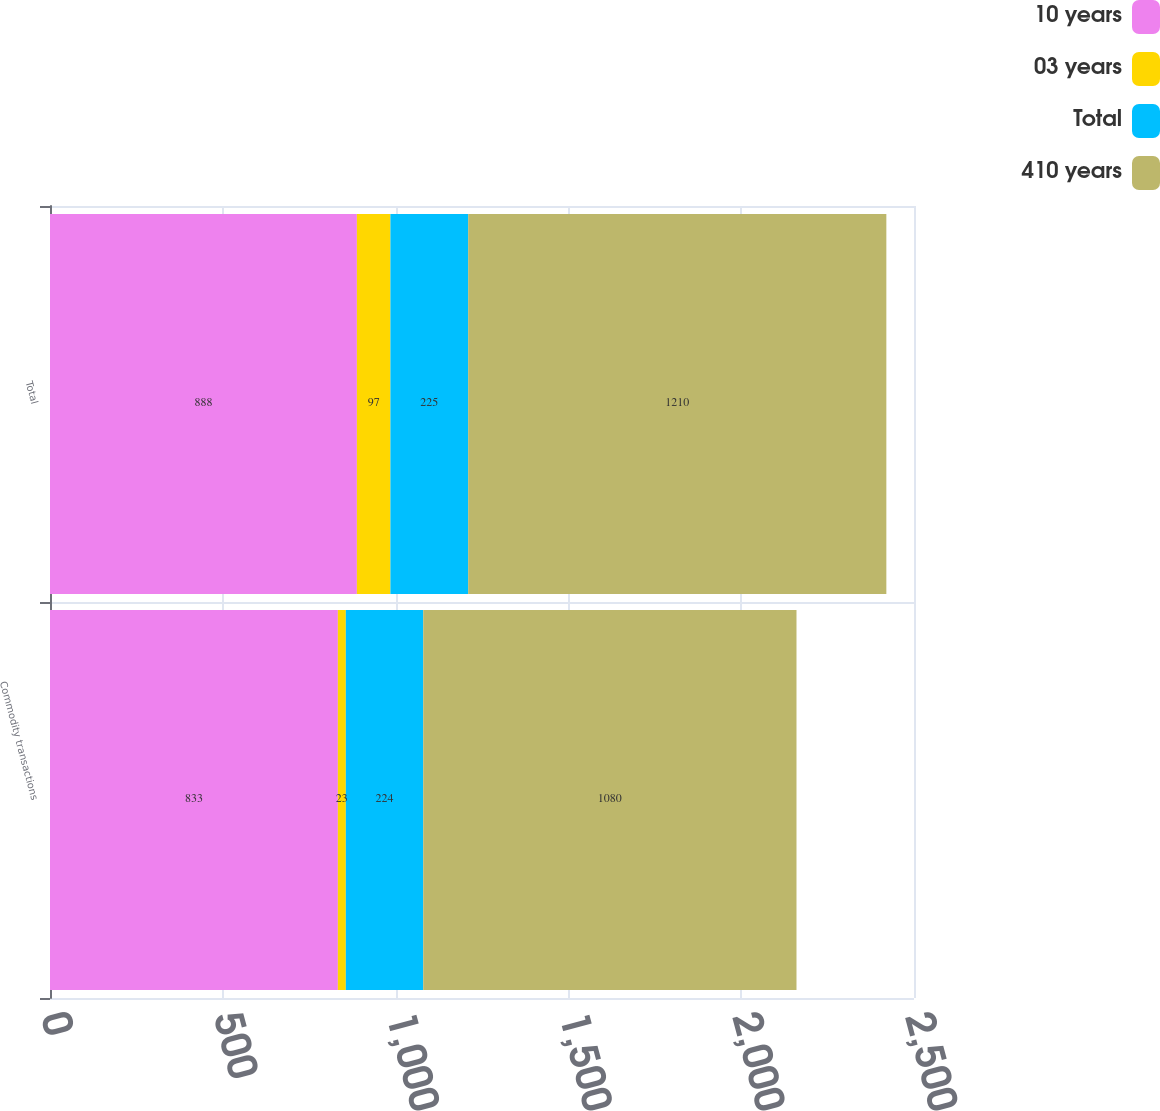Convert chart to OTSL. <chart><loc_0><loc_0><loc_500><loc_500><stacked_bar_chart><ecel><fcel>Commodity transactions<fcel>Total<nl><fcel>10 years<fcel>833<fcel>888<nl><fcel>03 years<fcel>23<fcel>97<nl><fcel>Total<fcel>224<fcel>225<nl><fcel>410 years<fcel>1080<fcel>1210<nl></chart> 